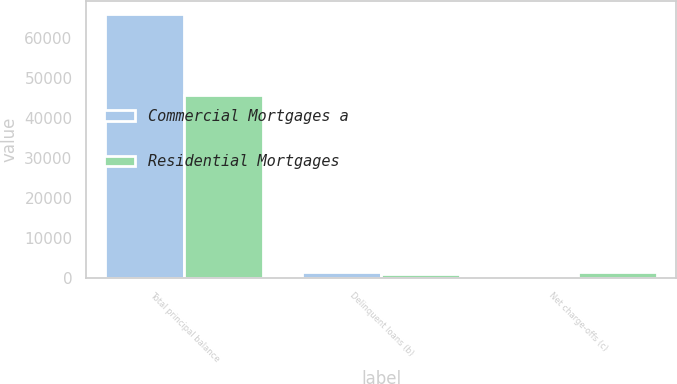Convert chart. <chart><loc_0><loc_0><loc_500><loc_500><stacked_bar_chart><ecel><fcel>Total principal balance<fcel>Delinquent loans (b)<fcel>Net charge-offs (c)<nl><fcel>Commercial Mortgages a<fcel>66081<fcel>1422<fcel>97<nl><fcel>Residential Mortgages<fcel>45855<fcel>941<fcel>1439<nl></chart> 